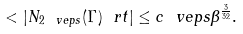Convert formula to latex. <formula><loc_0><loc_0><loc_500><loc_500>< | N _ { 2 \ v e p s } ( \Gamma ) \ r t | \leq c \ v e p s \beta ^ { \frac { 3 } { 3 2 } } .</formula> 